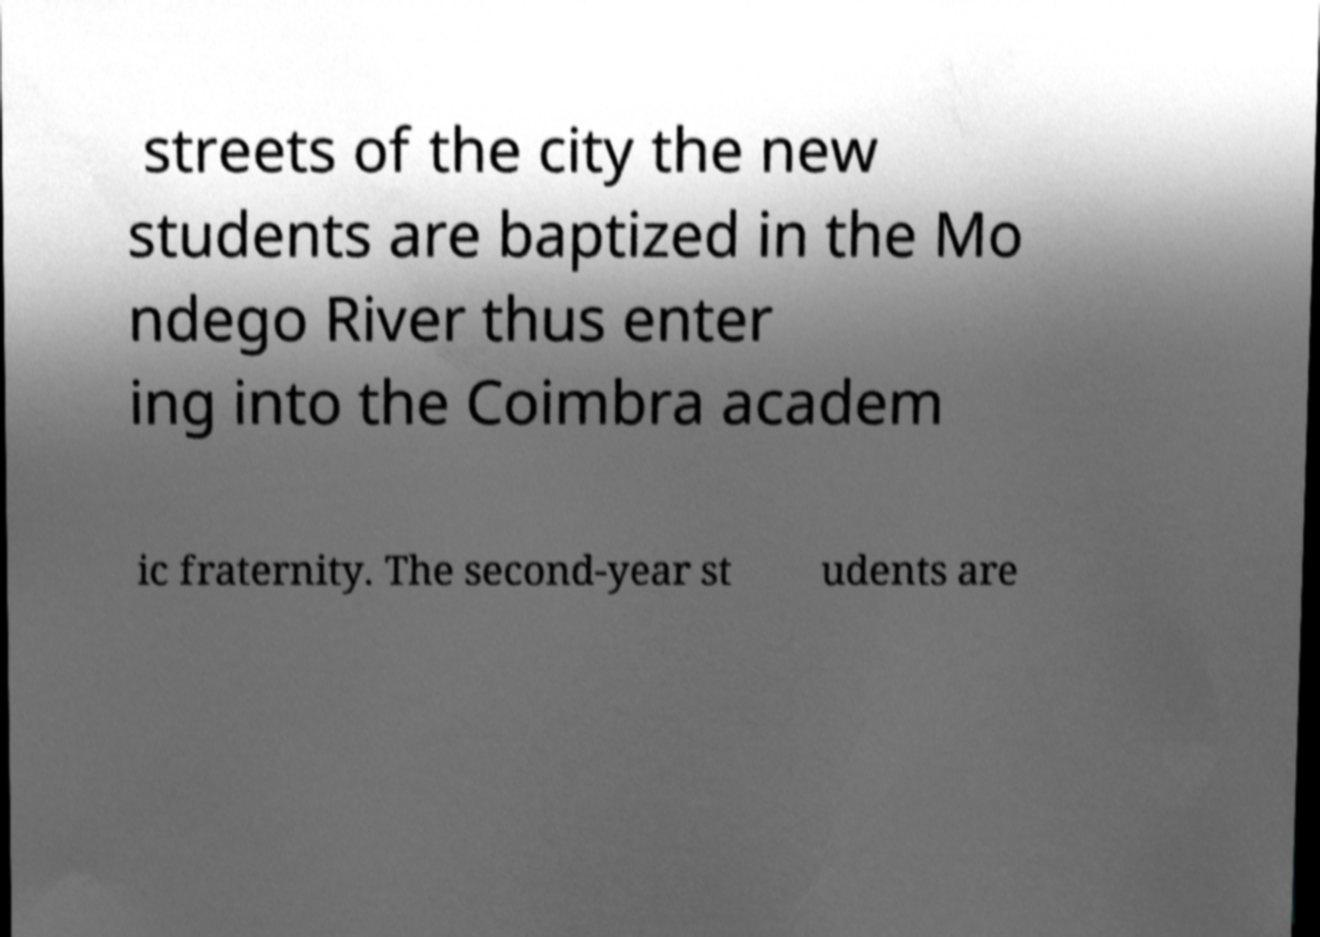For documentation purposes, I need the text within this image transcribed. Could you provide that? streets of the city the new students are baptized in the Mo ndego River thus enter ing into the Coimbra academ ic fraternity. The second-year st udents are 